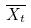Convert formula to latex. <formula><loc_0><loc_0><loc_500><loc_500>\overline { X _ { t } }</formula> 